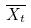Convert formula to latex. <formula><loc_0><loc_0><loc_500><loc_500>\overline { X _ { t } }</formula> 